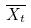Convert formula to latex. <formula><loc_0><loc_0><loc_500><loc_500>\overline { X _ { t } }</formula> 